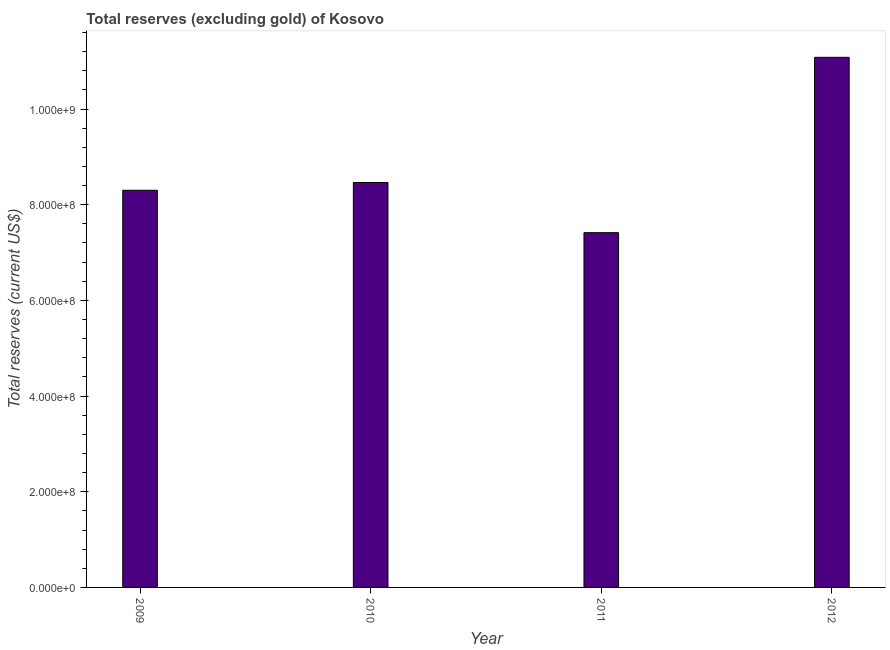Does the graph contain grids?
Provide a succinct answer. No. What is the title of the graph?
Offer a terse response. Total reserves (excluding gold) of Kosovo. What is the label or title of the X-axis?
Make the answer very short. Year. What is the label or title of the Y-axis?
Offer a very short reply. Total reserves (current US$). What is the total reserves (excluding gold) in 2011?
Provide a short and direct response. 7.42e+08. Across all years, what is the maximum total reserves (excluding gold)?
Your answer should be compact. 1.11e+09. Across all years, what is the minimum total reserves (excluding gold)?
Your answer should be very brief. 7.42e+08. In which year was the total reserves (excluding gold) maximum?
Your answer should be very brief. 2012. In which year was the total reserves (excluding gold) minimum?
Offer a very short reply. 2011. What is the sum of the total reserves (excluding gold)?
Offer a terse response. 3.53e+09. What is the difference between the total reserves (excluding gold) in 2009 and 2011?
Offer a very short reply. 8.87e+07. What is the average total reserves (excluding gold) per year?
Provide a succinct answer. 8.82e+08. What is the median total reserves (excluding gold)?
Provide a succinct answer. 8.38e+08. Do a majority of the years between 2010 and 2012 (inclusive) have total reserves (excluding gold) greater than 720000000 US$?
Provide a short and direct response. Yes. What is the ratio of the total reserves (excluding gold) in 2010 to that in 2011?
Your response must be concise. 1.14. What is the difference between the highest and the second highest total reserves (excluding gold)?
Your answer should be very brief. 2.62e+08. What is the difference between the highest and the lowest total reserves (excluding gold)?
Keep it short and to the point. 3.67e+08. In how many years, is the total reserves (excluding gold) greater than the average total reserves (excluding gold) taken over all years?
Provide a short and direct response. 1. How many bars are there?
Provide a succinct answer. 4. Are all the bars in the graph horizontal?
Give a very brief answer. No. How many years are there in the graph?
Your answer should be very brief. 4. Are the values on the major ticks of Y-axis written in scientific E-notation?
Ensure brevity in your answer.  Yes. What is the Total reserves (current US$) of 2009?
Provide a short and direct response. 8.30e+08. What is the Total reserves (current US$) in 2010?
Provide a succinct answer. 8.46e+08. What is the Total reserves (current US$) of 2011?
Offer a terse response. 7.42e+08. What is the Total reserves (current US$) in 2012?
Keep it short and to the point. 1.11e+09. What is the difference between the Total reserves (current US$) in 2009 and 2010?
Your answer should be compact. -1.62e+07. What is the difference between the Total reserves (current US$) in 2009 and 2011?
Provide a succinct answer. 8.87e+07. What is the difference between the Total reserves (current US$) in 2009 and 2012?
Offer a very short reply. -2.78e+08. What is the difference between the Total reserves (current US$) in 2010 and 2011?
Your response must be concise. 1.05e+08. What is the difference between the Total reserves (current US$) in 2010 and 2012?
Keep it short and to the point. -2.62e+08. What is the difference between the Total reserves (current US$) in 2011 and 2012?
Give a very brief answer. -3.67e+08. What is the ratio of the Total reserves (current US$) in 2009 to that in 2011?
Offer a terse response. 1.12. What is the ratio of the Total reserves (current US$) in 2009 to that in 2012?
Offer a very short reply. 0.75. What is the ratio of the Total reserves (current US$) in 2010 to that in 2011?
Offer a terse response. 1.14. What is the ratio of the Total reserves (current US$) in 2010 to that in 2012?
Make the answer very short. 0.76. What is the ratio of the Total reserves (current US$) in 2011 to that in 2012?
Provide a short and direct response. 0.67. 